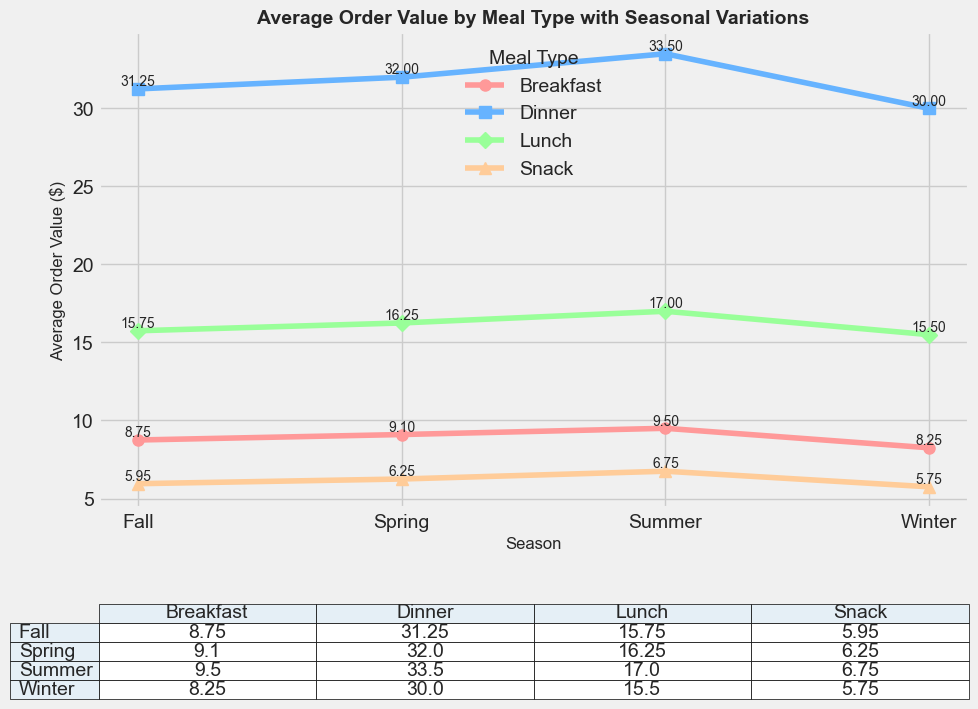Which meal type has the highest average order value in Summer? By looking at the plot markers and the data in the table, we see that Dinner has the highest average order value in Summer with a value of $33.50.
Answer: Dinner How does the average order value for Lunch in Winter compare to the average order value for Lunch in Summer? Comparing the data points for Lunch in Winter and Summer on the plot, Lunch has an average order value of $15.50 in Winter and $17.00 in Summer. $15.50 is less than $17.00.
Answer: Less than What is the difference in average order value between Dinner in Fall and Dinner in Winter? By checking the values from the plot and table, Dinner's average order value in Fall is $31.25 and in Winter it is $30.00. The difference is $31.25 - $30.00 = $1.25.
Answer: $1.25 Which season has the lowest average order value for Snacks? By examining the plot and table for Snack in different seasons, Winter has the lowest average order value for Snacks with a value of $5.75.
Answer: Winter What is the average order value for Breakfast across all seasons? Summing up the average order values for Breakfast from all seasons and dividing by the number of seasons: (8.25 + 9.10 + 9.50 + 8.75) / 4 = 35.60 / 4 = 8.90.
Answer: $8.90 Between which two consecutive seasons does Lunch see the highest increase in average order value? By checking the values, the highest increase occurs between Spring and Summer where the values go from $16.25 to $17.00. The difference is $17.00 - $16.25 = $0.75.
Answer: Spring to Summer Does Breakfast or Snack show more seasonal variation in average order value? Look at the range for Breakfast and Snack: Breakfast varies from $8.25 to $9.50 (range of 1.25) while Snack varies from $5.75 to $6.75 (range of 1.00). Breakfast shows more variation.
Answer: Breakfast How does the fall average order value for Dinner compare to the spring average order value for Lunch? By checking the values, Dinner in Fall has an average order value of $31.25 while Lunch in Spring is $16.25. $31.25 is greater than $16.25.
Answer: Greater What is the total average order value of all meal types in Spring? Sum the average order values in Spring: $9.10 (Breakfast) + $16.25 (Lunch) + $32.00 (Dinner) + $6.25 (Snack) = $63.60.
Answer: $63.60 In which season does Breakfast have the highest average order value? From the plot and table, Breakfast has the highest value in Summer with an average order value of $9.50.
Answer: Summer 